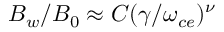Convert formula to latex. <formula><loc_0><loc_0><loc_500><loc_500>B _ { w } / B _ { 0 } \approx C ( \gamma / \omega _ { c e } ) ^ { \nu }</formula> 